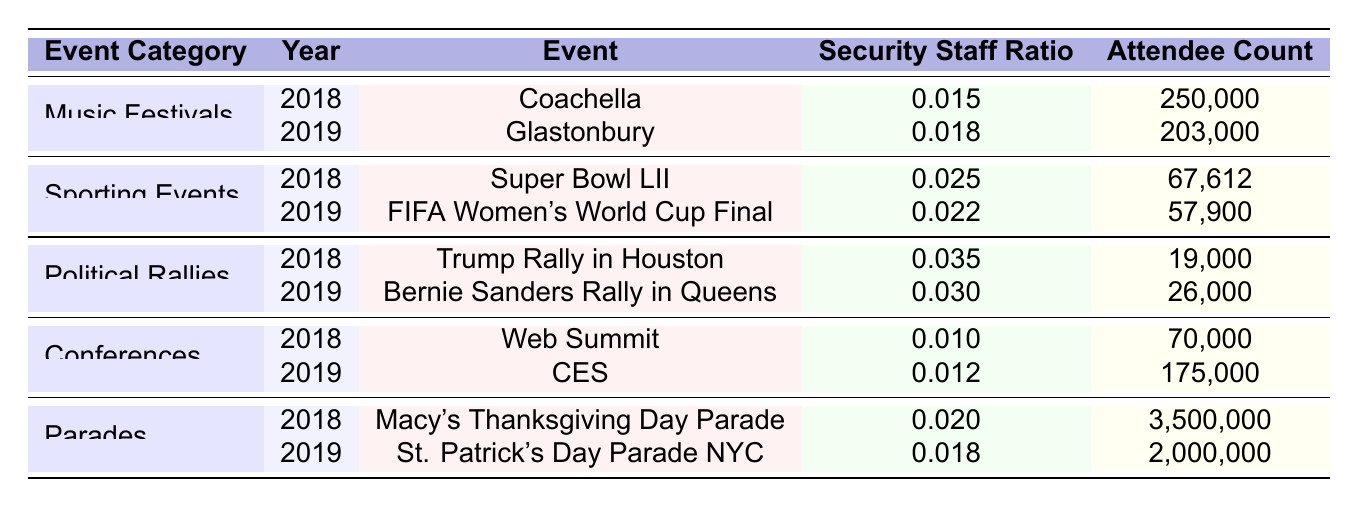What is the security staff ratio for Coachella in 2018? The table shows that Coachella, under the category of Music Festivals in 2018, has a Security Staff Ratio of 0.015.
Answer: 0.015 Which event had the highest number of attendees in 2018? By examining the Attendee Count column for the year 2018, Macy's Thanksgiving Day Parade has the highest number of attendees at 3,500,000.
Answer: 3,500,000 What is the average security staff ratio for sporting events in 2018? The security staff ratios for sporting events in 2018 are 0.025 (Super Bowl LII) and 0.022 (FIFA Women's World Cup Final). To find the average: (0.025 + 0.022) / 2 = 0.0235.
Answer: 0.0235 Did the security staff ratio increase from 2018 to 2019 for Political Rallies? Comparing the security staff ratios for Political Rallies: 2018 has a ratio of 0.035 (Trump Rally) and 2019 has a ratio of 0.030 (Bernie Sanders Rally). Since 0.035 > 0.030, the ratio decreased.
Answer: No Which event in 2019 had a smaller security staff ratio, CES or FIFA Women's World Cup Final? CES in 2019 had a security staff ratio of 0.012, while FIFA Women's World Cup Final had a ratio of 0.022. Since 0.012 < 0.022, CES had a smaller ratio.
Answer: CES What was the total attendee count for all events in 2019? The total attendee count for 2019 is the sum of attendees from all events: 203,000 (Glastonbury) + 57,900 (FIFA) + 26,000 (Bernie) + 175,000 (CES) + 2,000,000 (St. Patrick's Day) = 2,461,900.
Answer: 2,461,900 What percentage of attendees were present at Macy's Thanksgiving Day Parade compared to the total attendees across all events in 2018? The total attendees in 2018 is 250,000 (Coachella) + 67,612 (Super Bowl LII) + 19,000 (Trump Rally) + 70,000 (Web Summit) + 3,500,000 (Macy's Parade) = 3,906,612. The percentage is (3,500,000 / 3,906,612) * 100 ≈ 89.7%.
Answer: 89.7% Was the security staff ratio for Glastonbury higher or lower than that for the Super Bowl LII? Glastonbury’s ratio in 2019 is 0.018, while Super Bowl LII in 2018 is 0.025. Since 0.018 < 0.025, it was lower.
Answer: Lower How much did the security staff ratio change for Parades from 2018 to 2019? The ratio for Parades in 2018 is 0.020, and in 2019 it is 0.018. The change is 0.020 - 0.018 = 0.002, indicating a decrease.
Answer: Decreased by 0.002 